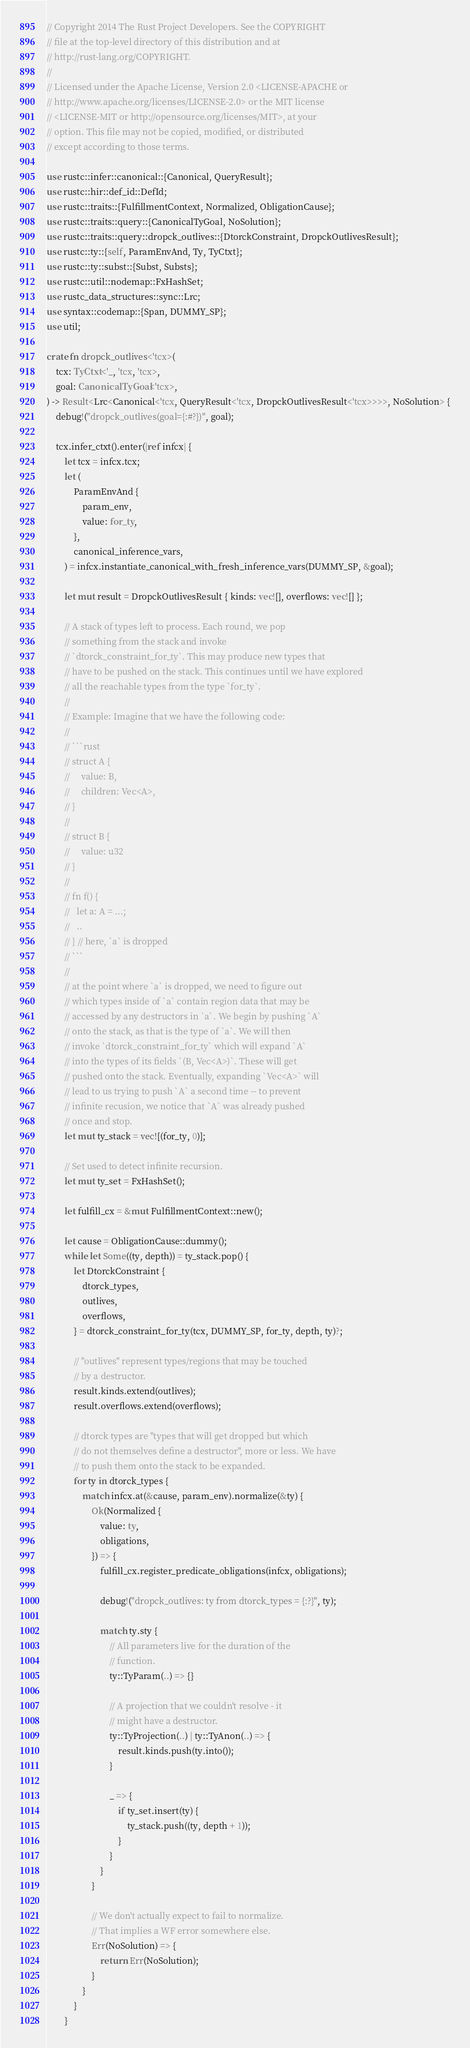Convert code to text. <code><loc_0><loc_0><loc_500><loc_500><_Rust_>// Copyright 2014 The Rust Project Developers. See the COPYRIGHT
// file at the top-level directory of this distribution and at
// http://rust-lang.org/COPYRIGHT.
//
// Licensed under the Apache License, Version 2.0 <LICENSE-APACHE or
// http://www.apache.org/licenses/LICENSE-2.0> or the MIT license
// <LICENSE-MIT or http://opensource.org/licenses/MIT>, at your
// option. This file may not be copied, modified, or distributed
// except according to those terms.

use rustc::infer::canonical::{Canonical, QueryResult};
use rustc::hir::def_id::DefId;
use rustc::traits::{FulfillmentContext, Normalized, ObligationCause};
use rustc::traits::query::{CanonicalTyGoal, NoSolution};
use rustc::traits::query::dropck_outlives::{DtorckConstraint, DropckOutlivesResult};
use rustc::ty::{self, ParamEnvAnd, Ty, TyCtxt};
use rustc::ty::subst::{Subst, Substs};
use rustc::util::nodemap::FxHashSet;
use rustc_data_structures::sync::Lrc;
use syntax::codemap::{Span, DUMMY_SP};
use util;

crate fn dropck_outlives<'tcx>(
    tcx: TyCtxt<'_, 'tcx, 'tcx>,
    goal: CanonicalTyGoal<'tcx>,
) -> Result<Lrc<Canonical<'tcx, QueryResult<'tcx, DropckOutlivesResult<'tcx>>>>, NoSolution> {
    debug!("dropck_outlives(goal={:#?})", goal);

    tcx.infer_ctxt().enter(|ref infcx| {
        let tcx = infcx.tcx;
        let (
            ParamEnvAnd {
                param_env,
                value: for_ty,
            },
            canonical_inference_vars,
        ) = infcx.instantiate_canonical_with_fresh_inference_vars(DUMMY_SP, &goal);

        let mut result = DropckOutlivesResult { kinds: vec![], overflows: vec![] };

        // A stack of types left to process. Each round, we pop
        // something from the stack and invoke
        // `dtorck_constraint_for_ty`. This may produce new types that
        // have to be pushed on the stack. This continues until we have explored
        // all the reachable types from the type `for_ty`.
        //
        // Example: Imagine that we have the following code:
        //
        // ```rust
        // struct A {
        //     value: B,
        //     children: Vec<A>,
        // }
        //
        // struct B {
        //     value: u32
        // }
        //
        // fn f() {
        //   let a: A = ...;
        //   ..
        // } // here, `a` is dropped
        // ```
        //
        // at the point where `a` is dropped, we need to figure out
        // which types inside of `a` contain region data that may be
        // accessed by any destructors in `a`. We begin by pushing `A`
        // onto the stack, as that is the type of `a`. We will then
        // invoke `dtorck_constraint_for_ty` which will expand `A`
        // into the types of its fields `(B, Vec<A>)`. These will get
        // pushed onto the stack. Eventually, expanding `Vec<A>` will
        // lead to us trying to push `A` a second time -- to prevent
        // infinite recusion, we notice that `A` was already pushed
        // once and stop.
        let mut ty_stack = vec![(for_ty, 0)];

        // Set used to detect infinite recursion.
        let mut ty_set = FxHashSet();

        let fulfill_cx = &mut FulfillmentContext::new();

        let cause = ObligationCause::dummy();
        while let Some((ty, depth)) = ty_stack.pop() {
            let DtorckConstraint {
                dtorck_types,
                outlives,
                overflows,
            } = dtorck_constraint_for_ty(tcx, DUMMY_SP, for_ty, depth, ty)?;

            // "outlives" represent types/regions that may be touched
            // by a destructor.
            result.kinds.extend(outlives);
            result.overflows.extend(overflows);

            // dtorck types are "types that will get dropped but which
            // do not themselves define a destructor", more or less. We have
            // to push them onto the stack to be expanded.
            for ty in dtorck_types {
                match infcx.at(&cause, param_env).normalize(&ty) {
                    Ok(Normalized {
                        value: ty,
                        obligations,
                    }) => {
                        fulfill_cx.register_predicate_obligations(infcx, obligations);

                        debug!("dropck_outlives: ty from dtorck_types = {:?}", ty);

                        match ty.sty {
                            // All parameters live for the duration of the
                            // function.
                            ty::TyParam(..) => {}

                            // A projection that we couldn't resolve - it
                            // might have a destructor.
                            ty::TyProjection(..) | ty::TyAnon(..) => {
                                result.kinds.push(ty.into());
                            }

                            _ => {
                                if ty_set.insert(ty) {
                                    ty_stack.push((ty, depth + 1));
                                }
                            }
                        }
                    }

                    // We don't actually expect to fail to normalize.
                    // That implies a WF error somewhere else.
                    Err(NoSolution) => {
                        return Err(NoSolution);
                    }
                }
            }
        }
</code> 